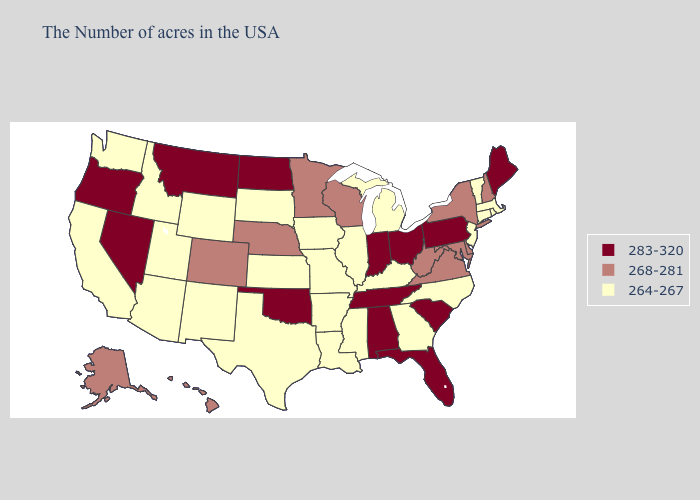What is the value of Louisiana?
Short answer required. 264-267. Which states hav the highest value in the MidWest?
Give a very brief answer. Ohio, Indiana, North Dakota. Name the states that have a value in the range 268-281?
Be succinct. New Hampshire, New York, Delaware, Maryland, Virginia, West Virginia, Wisconsin, Minnesota, Nebraska, Colorado, Alaska, Hawaii. Does Utah have the highest value in the West?
Give a very brief answer. No. Does New York have the highest value in the Northeast?
Be succinct. No. Among the states that border South Dakota , which have the highest value?
Write a very short answer. North Dakota, Montana. How many symbols are there in the legend?
Answer briefly. 3. What is the highest value in the USA?
Give a very brief answer. 283-320. Does South Dakota have the highest value in the MidWest?
Concise answer only. No. What is the lowest value in the USA?
Quick response, please. 264-267. Which states have the lowest value in the USA?
Write a very short answer. Massachusetts, Rhode Island, Vermont, Connecticut, New Jersey, North Carolina, Georgia, Michigan, Kentucky, Illinois, Mississippi, Louisiana, Missouri, Arkansas, Iowa, Kansas, Texas, South Dakota, Wyoming, New Mexico, Utah, Arizona, Idaho, California, Washington. What is the highest value in states that border California?
Short answer required. 283-320. How many symbols are there in the legend?
Quick response, please. 3. Name the states that have a value in the range 268-281?
Quick response, please. New Hampshire, New York, Delaware, Maryland, Virginia, West Virginia, Wisconsin, Minnesota, Nebraska, Colorado, Alaska, Hawaii. What is the lowest value in the MidWest?
Short answer required. 264-267. 